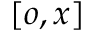Convert formula to latex. <formula><loc_0><loc_0><loc_500><loc_500>[ o , x ]</formula> 